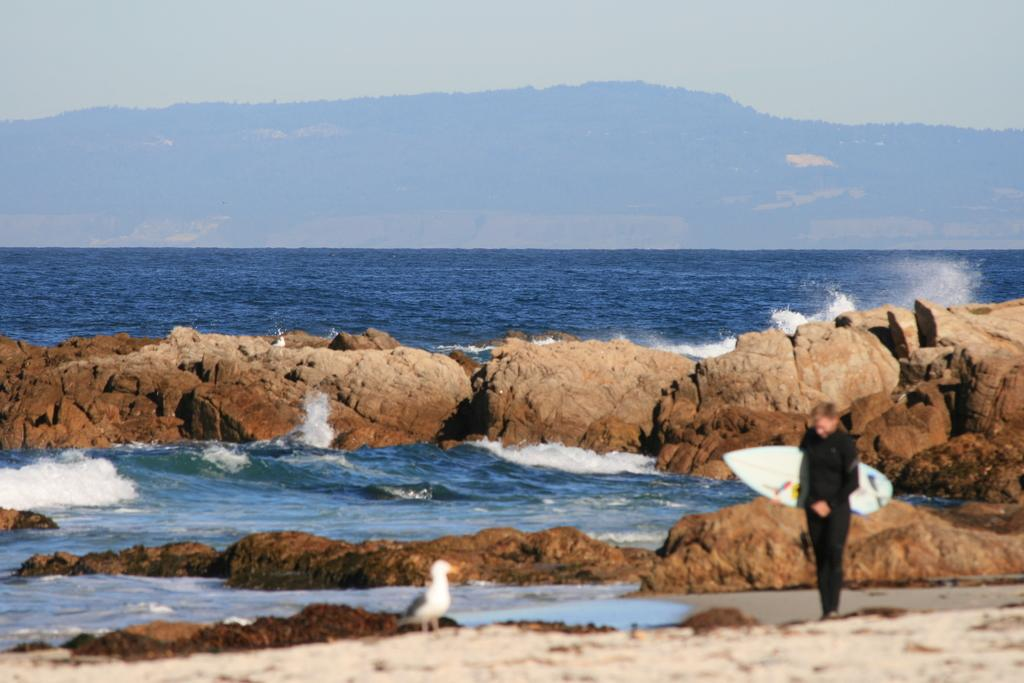Who or what is present in the image? There is a person and a bird in the image. What is the environment like in the image? There is water visible in the image, and there is a mountain in the image. How many brothers does the bird have in the image? There is no information about the bird's brothers in the image, as the focus is on the person and the bird themselves. 